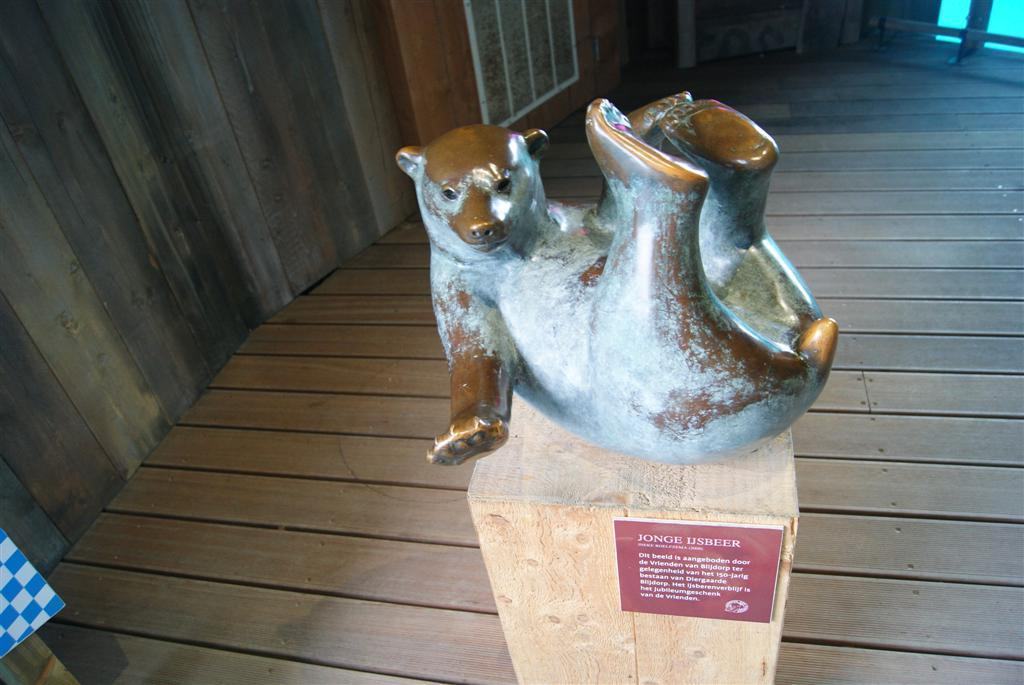What is the main subject of the image? There is a sculpture in the image. Can you describe the setting of the sculpture? The sculpture is in front of a wooden wall. What type of brush is being used to paint the flower on the sculpture? There is no flower or brush present on the sculpture in the image. 